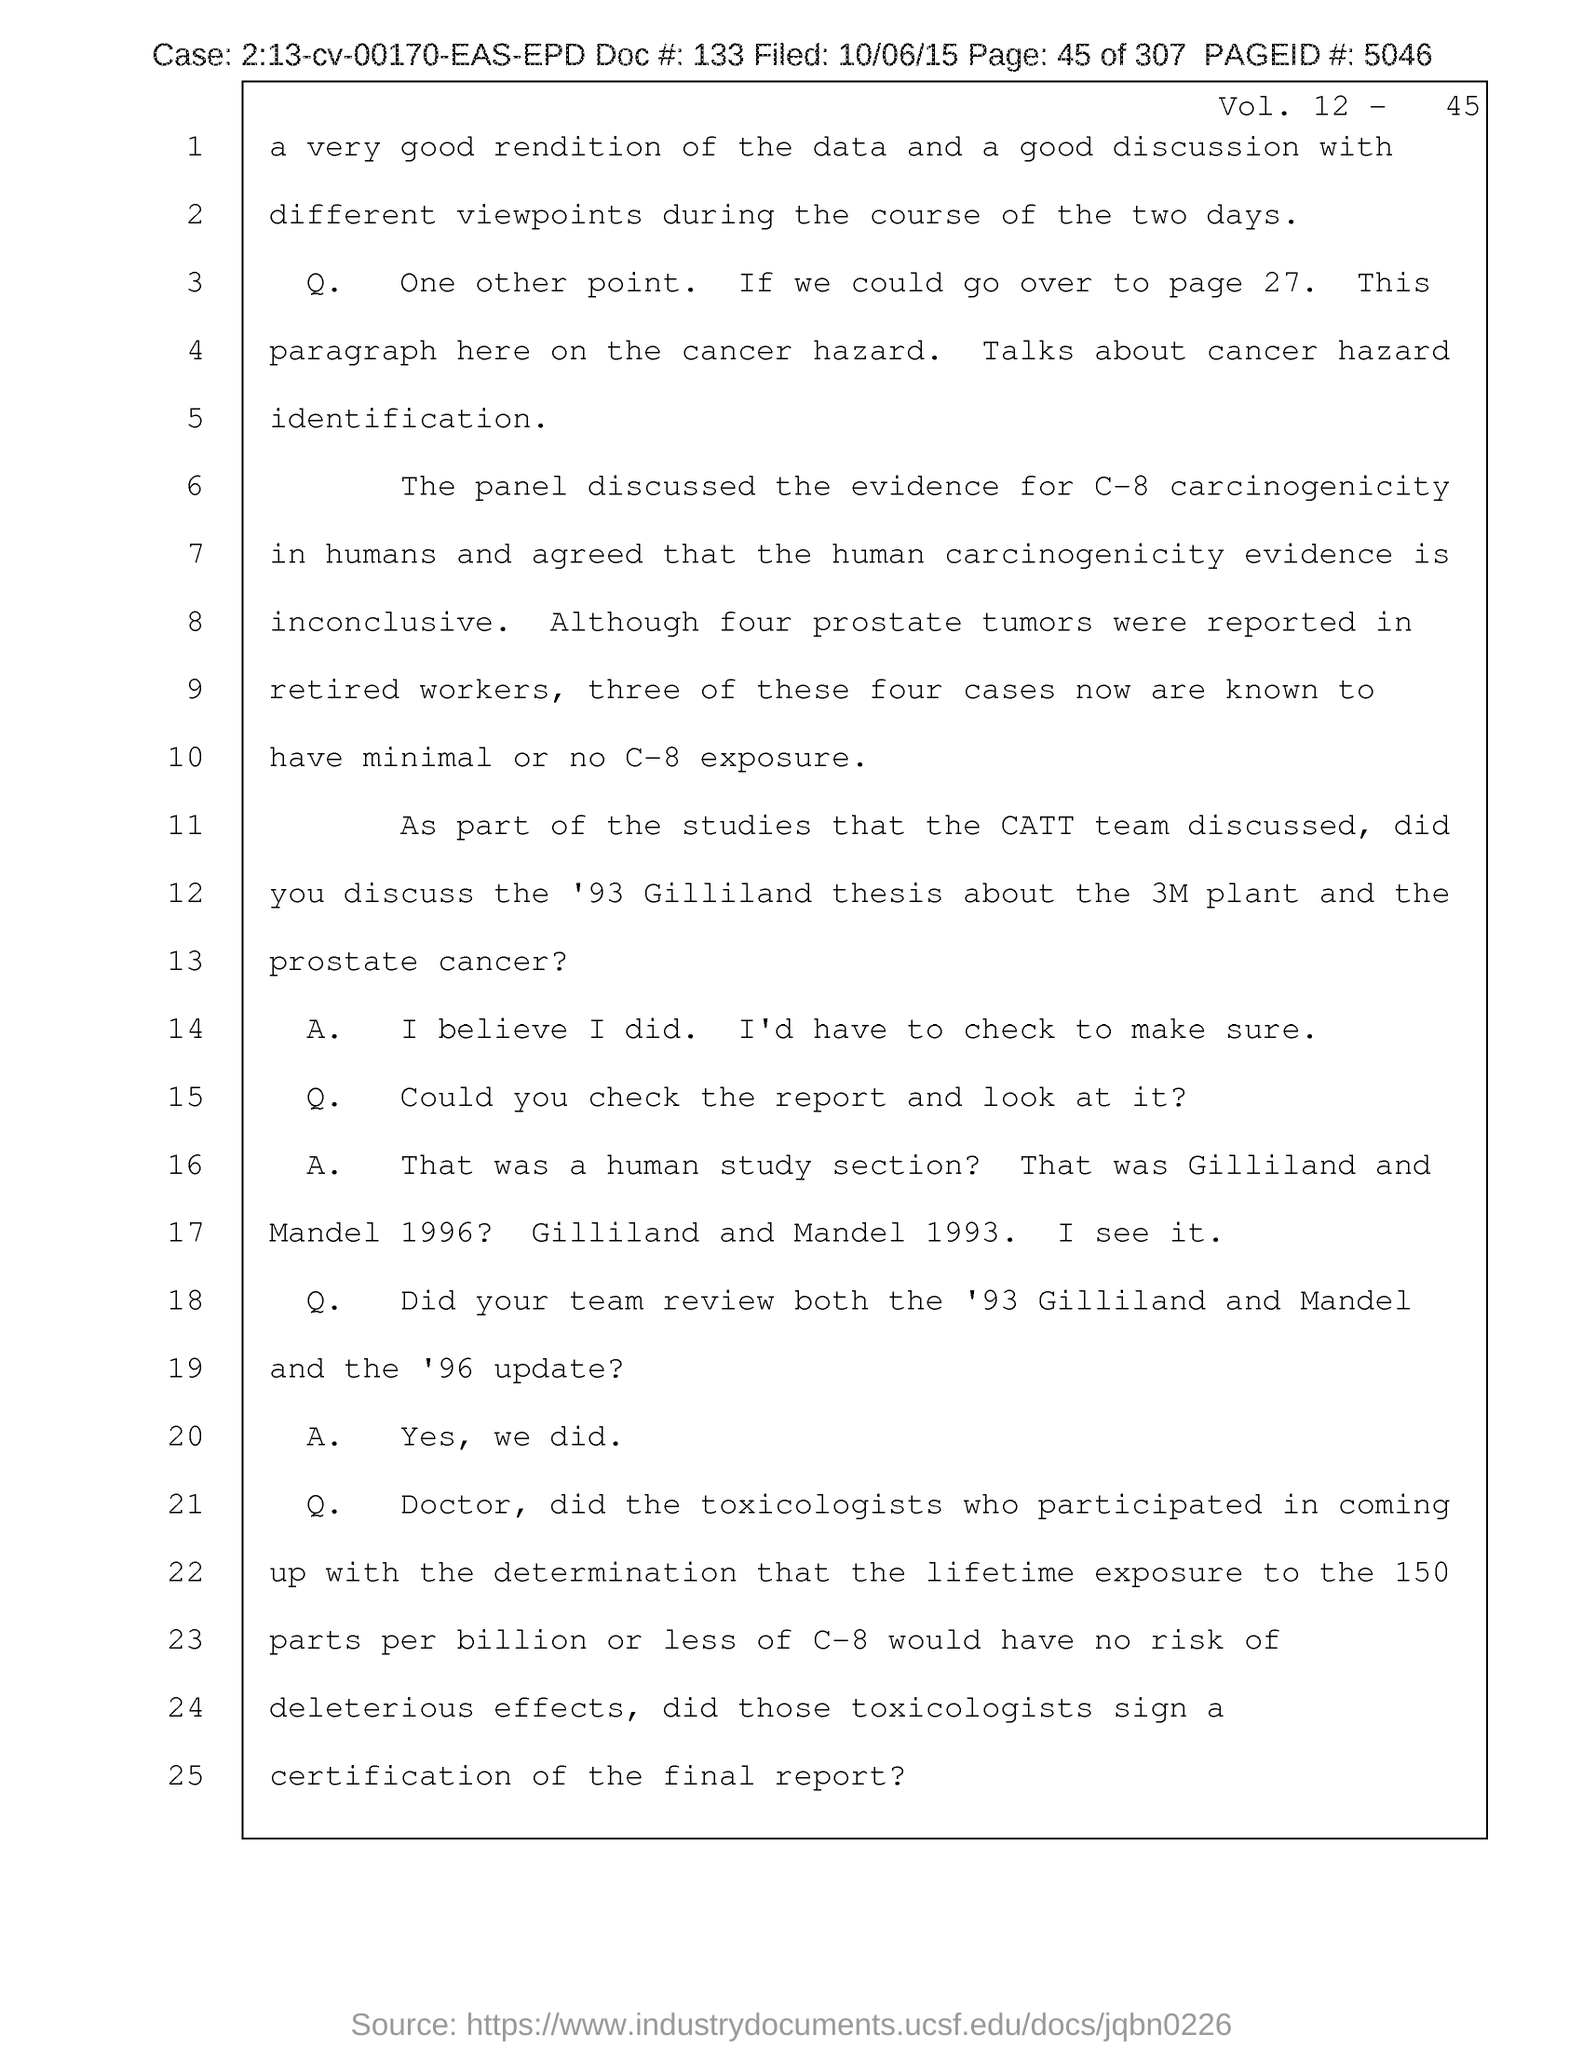Mention a couple of crucial points in this snapshot. Please provide the document number referenced in the document, which is 133.. The page number mentioned in this document is 45. The document contains a volume number of 12. The page number mentioned in the document is 5046. What is the case number mentioned in the document? It is 2:13-cv-00170-EAS-EPD.. 